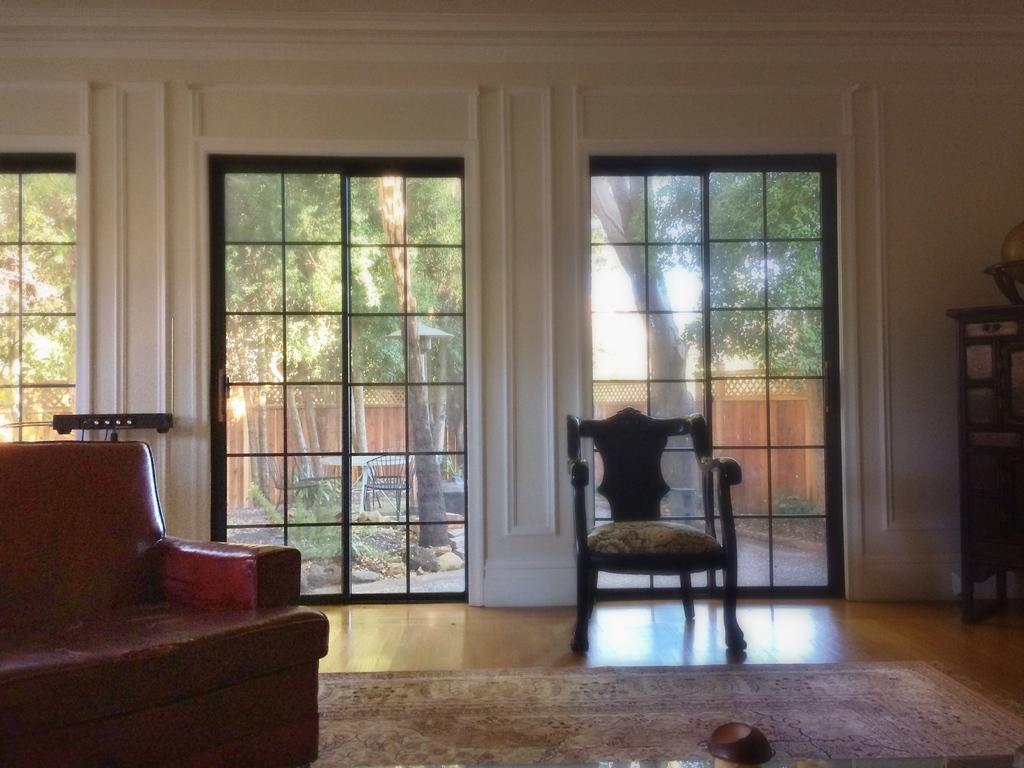What type of furniture is in the foreground of the image? There is a couch in the image. What other furniture can be seen in the background of the image? There is a chair in the background of the image. What can be seen through the window in the background of the image? The sky is visible in the background of the image. What type of vegetation is present in the background of the image? There is a plant in the background of the image. What type of jam is being served on the couch in the image? There is no jam present in the image; it features a couch, a chair, a window, a plant, and the sky. 